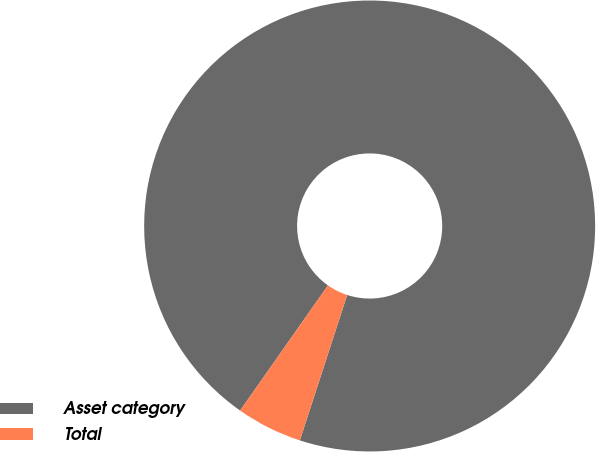Convert chart to OTSL. <chart><loc_0><loc_0><loc_500><loc_500><pie_chart><fcel>Asset category<fcel>Total<nl><fcel>95.27%<fcel>4.73%<nl></chart> 